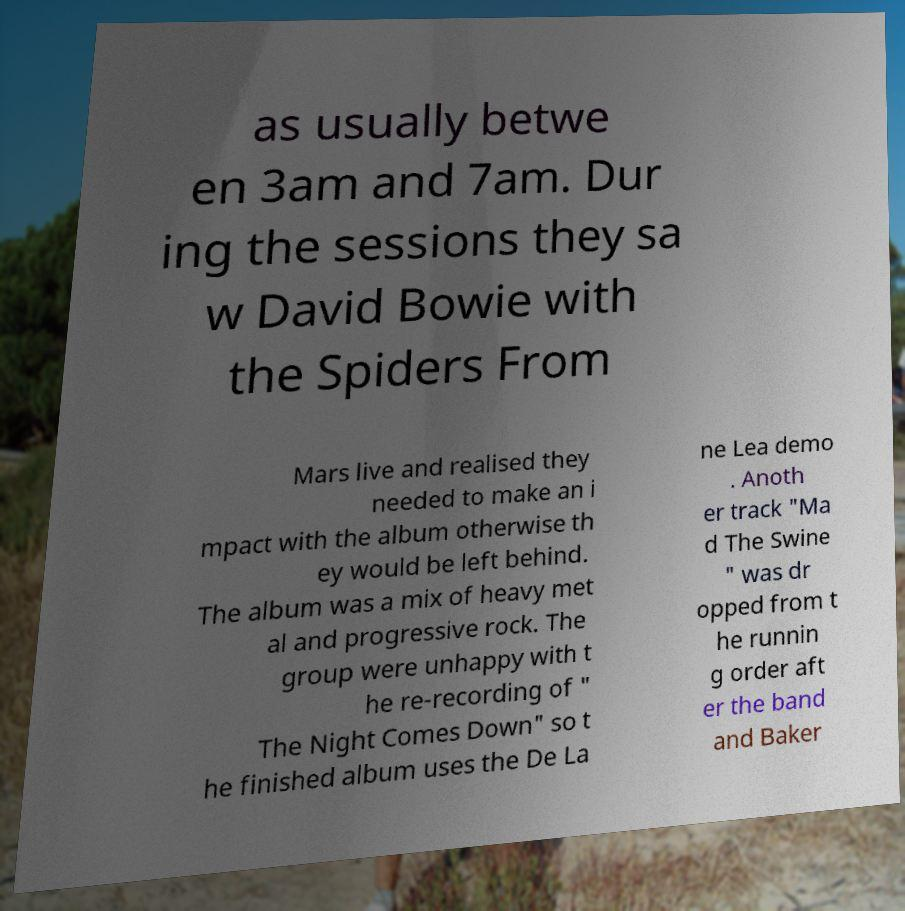Can you read and provide the text displayed in the image?This photo seems to have some interesting text. Can you extract and type it out for me? as usually betwe en 3am and 7am. Dur ing the sessions they sa w David Bowie with the Spiders From Mars live and realised they needed to make an i mpact with the album otherwise th ey would be left behind. The album was a mix of heavy met al and progressive rock. The group were unhappy with t he re-recording of " The Night Comes Down" so t he finished album uses the De La ne Lea demo . Anoth er track "Ma d The Swine " was dr opped from t he runnin g order aft er the band and Baker 